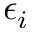<formula> <loc_0><loc_0><loc_500><loc_500>\epsilon _ { i }</formula> 